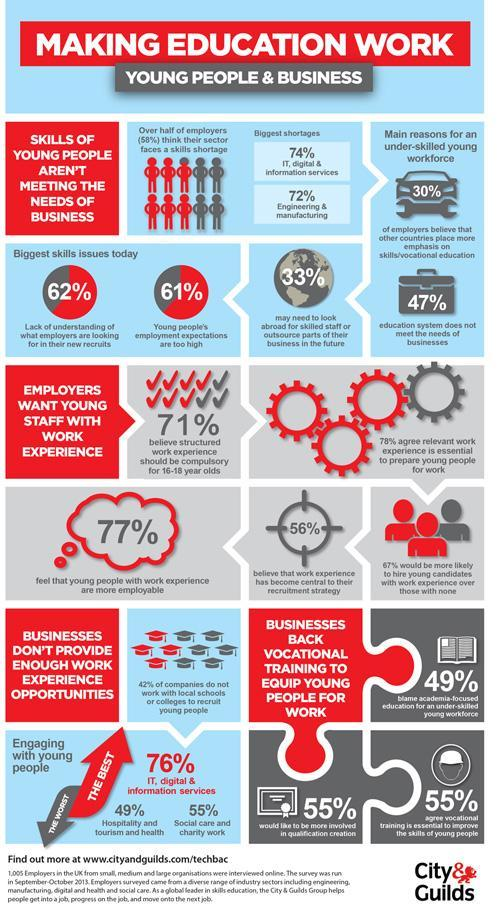What percentage of companies work with local schools or colleges to recruit young people?
Answer the question with a short phrase. 58% What percentage of the education system does meet the needs of the business? 53% What percentage believe that work experience has not become central to their recruitment strategy? 44% 